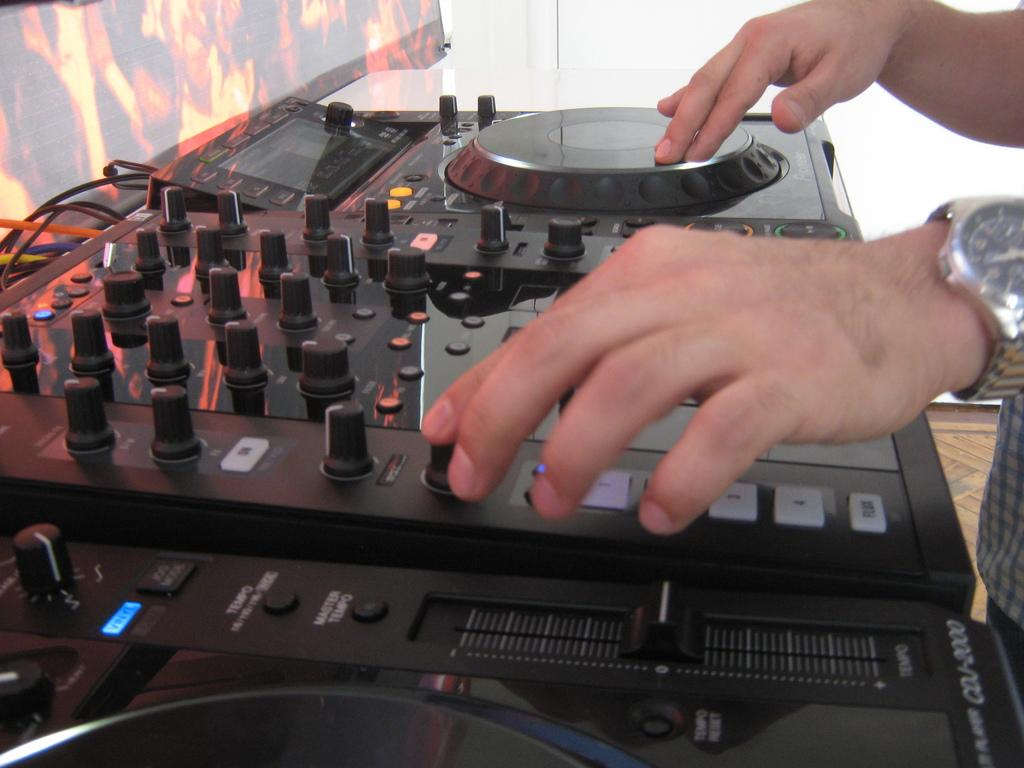What is the main object in the image related to music? There is a music controlling machine in the image. Can you describe the person in the image? There is a person standing on the right side of the image. What can be seen on the left side of the image? There is a poster on the left side of the image. What is visible at the top of the image? The sky is visible at the top of the image. How many units of thread are being used by the person in the image? There is no thread or unit mentioned in the image; it features a music controlling machine and a person standing nearby. 